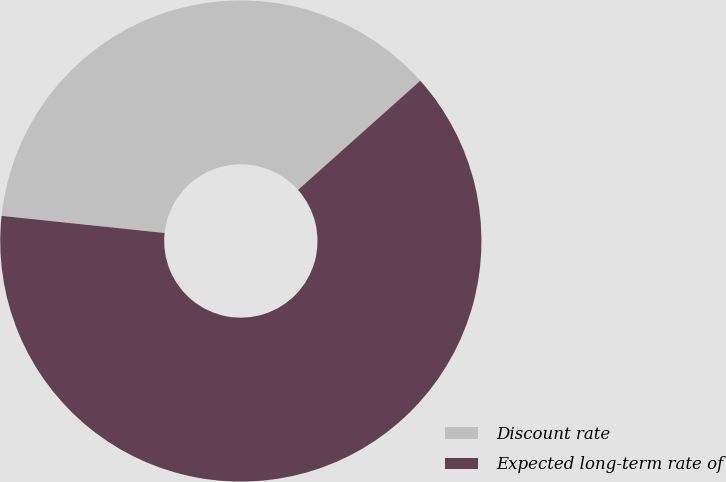Convert chart to OTSL. <chart><loc_0><loc_0><loc_500><loc_500><pie_chart><fcel>Discount rate<fcel>Expected long-term rate of<nl><fcel>36.73%<fcel>63.27%<nl></chart> 